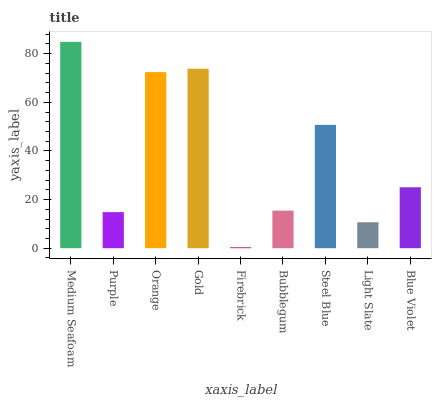Is Firebrick the minimum?
Answer yes or no. Yes. Is Medium Seafoam the maximum?
Answer yes or no. Yes. Is Purple the minimum?
Answer yes or no. No. Is Purple the maximum?
Answer yes or no. No. Is Medium Seafoam greater than Purple?
Answer yes or no. Yes. Is Purple less than Medium Seafoam?
Answer yes or no. Yes. Is Purple greater than Medium Seafoam?
Answer yes or no. No. Is Medium Seafoam less than Purple?
Answer yes or no. No. Is Blue Violet the high median?
Answer yes or no. Yes. Is Blue Violet the low median?
Answer yes or no. Yes. Is Orange the high median?
Answer yes or no. No. Is Orange the low median?
Answer yes or no. No. 